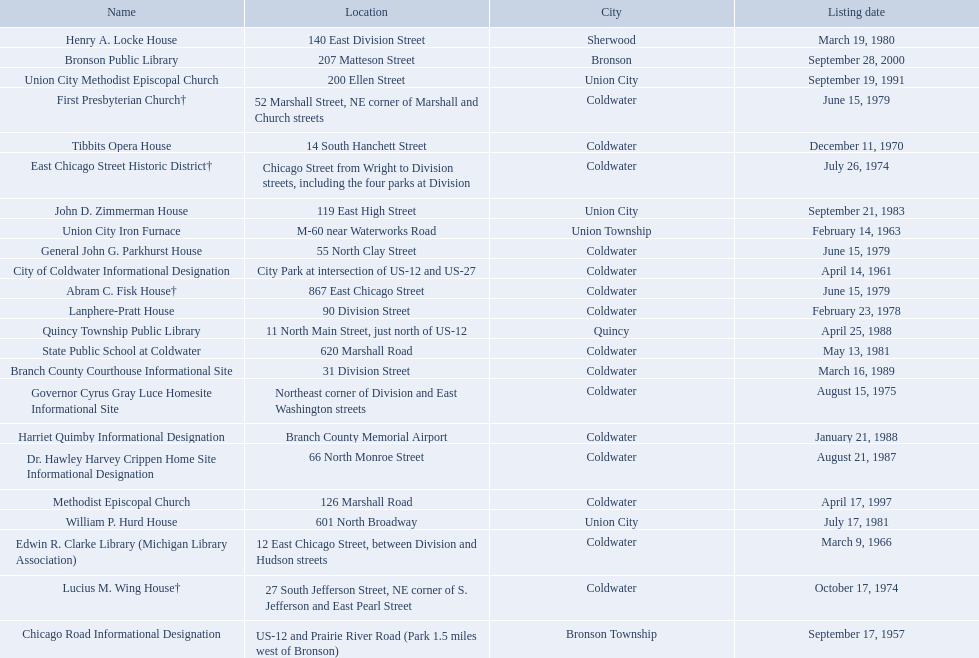Are there any listing dates that happened before 1960? September 17, 1957. What is the name of the site that was listed before 1960? Chicago Road Informational Designation. 